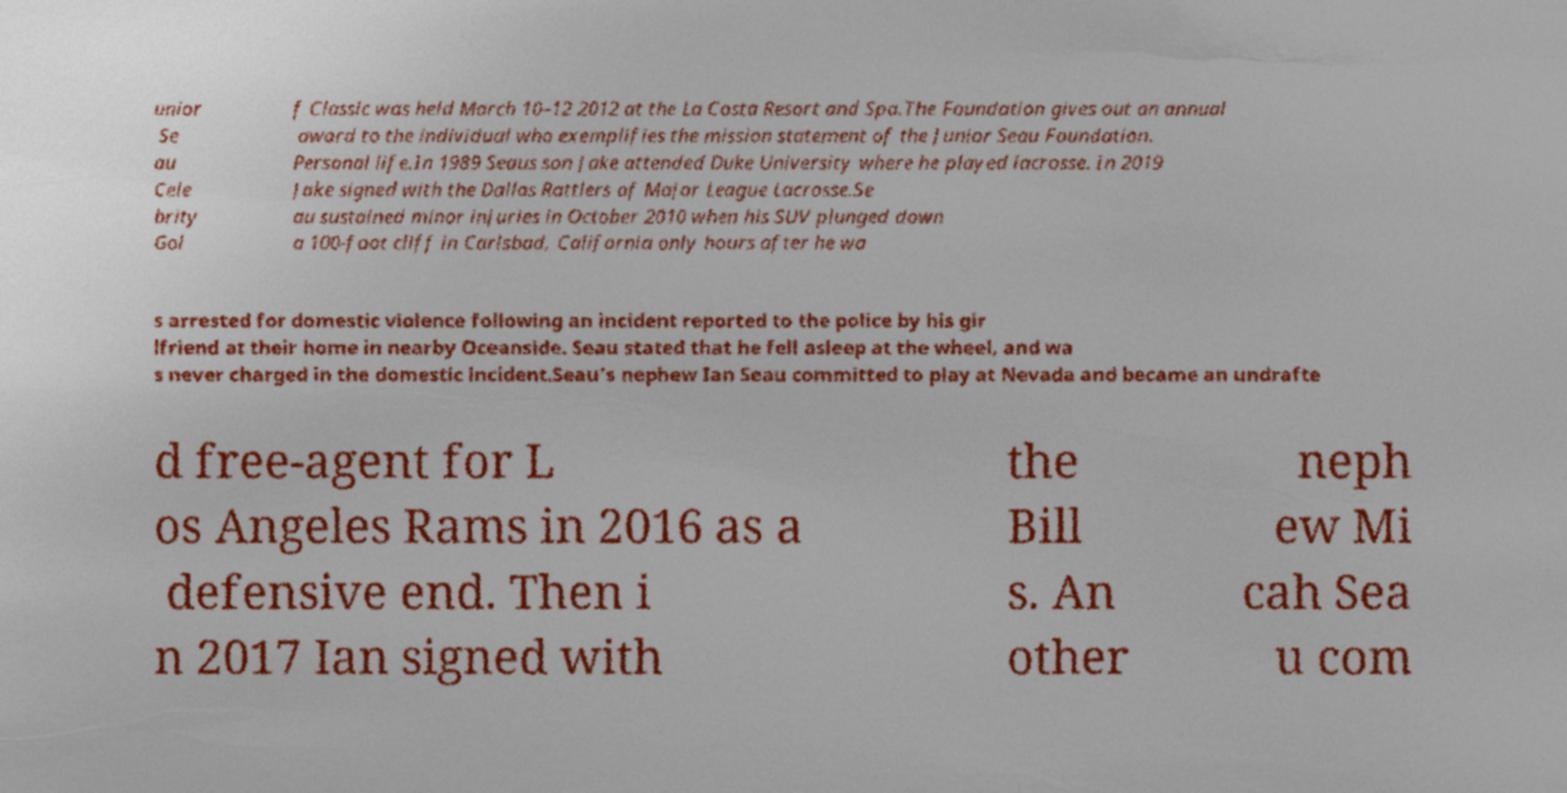I need the written content from this picture converted into text. Can you do that? unior Se au Cele brity Gol f Classic was held March 10–12 2012 at the La Costa Resort and Spa.The Foundation gives out an annual award to the individual who exemplifies the mission statement of the Junior Seau Foundation. Personal life.In 1989 Seaus son Jake attended Duke University where he played lacrosse. In 2019 Jake signed with the Dallas Rattlers of Major League Lacrosse.Se au sustained minor injuries in October 2010 when his SUV plunged down a 100-foot cliff in Carlsbad, California only hours after he wa s arrested for domestic violence following an incident reported to the police by his gir lfriend at their home in nearby Oceanside. Seau stated that he fell asleep at the wheel, and wa s never charged in the domestic incident.Seau's nephew Ian Seau committed to play at Nevada and became an undrafte d free-agent for L os Angeles Rams in 2016 as a defensive end. Then i n 2017 Ian signed with the Bill s. An other neph ew Mi cah Sea u com 